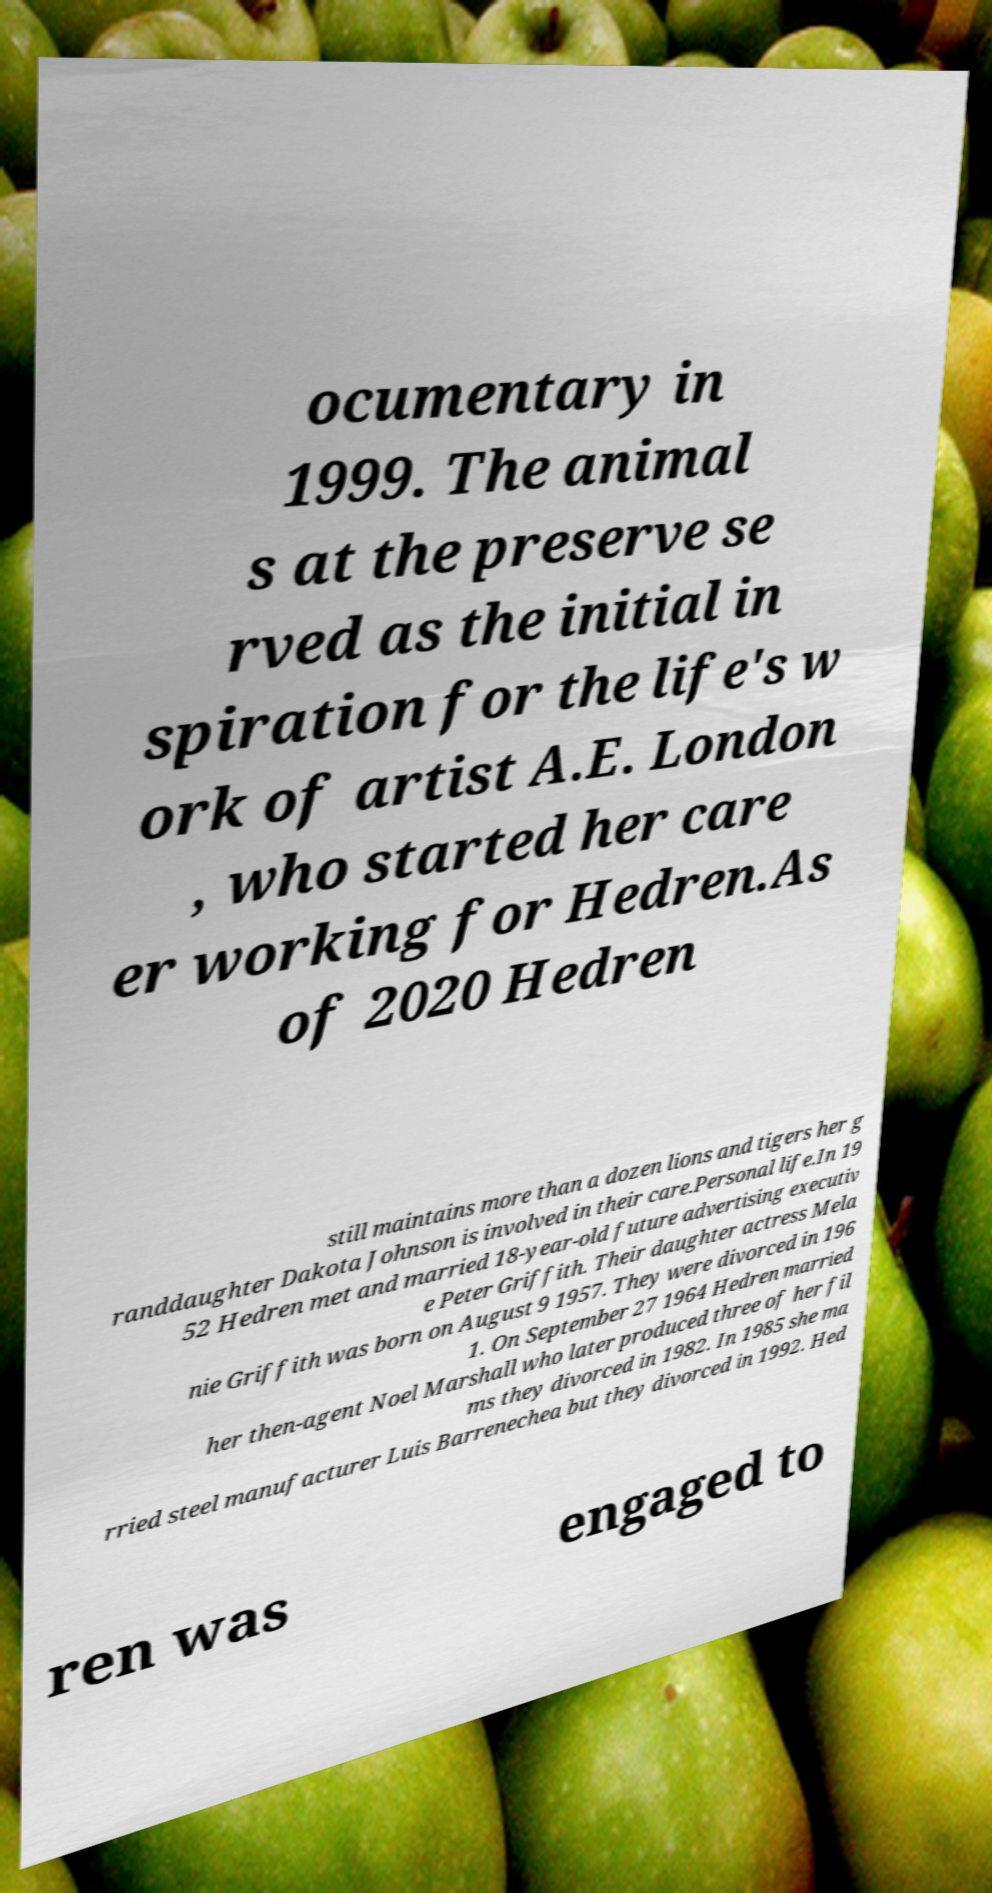I need the written content from this picture converted into text. Can you do that? ocumentary in 1999. The animal s at the preserve se rved as the initial in spiration for the life's w ork of artist A.E. London , who started her care er working for Hedren.As of 2020 Hedren still maintains more than a dozen lions and tigers her g randdaughter Dakota Johnson is involved in their care.Personal life.In 19 52 Hedren met and married 18-year-old future advertising executiv e Peter Griffith. Their daughter actress Mela nie Griffith was born on August 9 1957. They were divorced in 196 1. On September 27 1964 Hedren married her then-agent Noel Marshall who later produced three of her fil ms they divorced in 1982. In 1985 she ma rried steel manufacturer Luis Barrenechea but they divorced in 1992. Hed ren was engaged to 